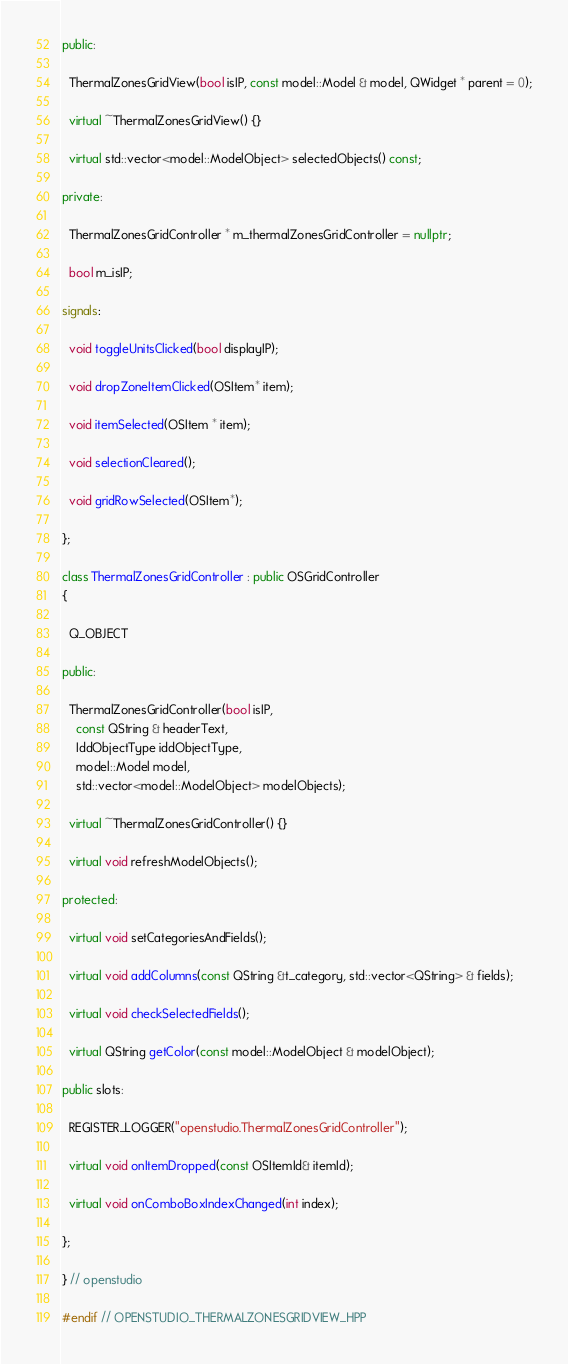<code> <loc_0><loc_0><loc_500><loc_500><_C++_>
public:

  ThermalZonesGridView(bool isIP, const model::Model & model, QWidget * parent = 0);

  virtual ~ThermalZonesGridView() {}

  virtual std::vector<model::ModelObject> selectedObjects() const;

private:

  ThermalZonesGridController * m_thermalZonesGridController = nullptr;

  bool m_isIP;

signals:

  void toggleUnitsClicked(bool displayIP);

  void dropZoneItemClicked(OSItem* item);

  void itemSelected(OSItem * item);

  void selectionCleared();

  void gridRowSelected(OSItem*);

};

class ThermalZonesGridController : public OSGridController
{

  Q_OBJECT

public:

  ThermalZonesGridController(bool isIP,
    const QString & headerText,
    IddObjectType iddObjectType,
    model::Model model,
    std::vector<model::ModelObject> modelObjects);

  virtual ~ThermalZonesGridController() {}

  virtual void refreshModelObjects();

protected:

  virtual void setCategoriesAndFields();

  virtual void addColumns(const QString &t_category, std::vector<QString> & fields);

  virtual void checkSelectedFields();

  virtual QString getColor(const model::ModelObject & modelObject);

public slots:

  REGISTER_LOGGER("openstudio.ThermalZonesGridController");

  virtual void onItemDropped(const OSItemId& itemId);

  virtual void onComboBoxIndexChanged(int index);

};

} // openstudio

#endif // OPENSTUDIO_THERMALZONESGRIDVIEW_HPP

</code> 